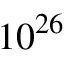Convert formula to latex. <formula><loc_0><loc_0><loc_500><loc_500>1 0 ^ { 2 6 }</formula> 